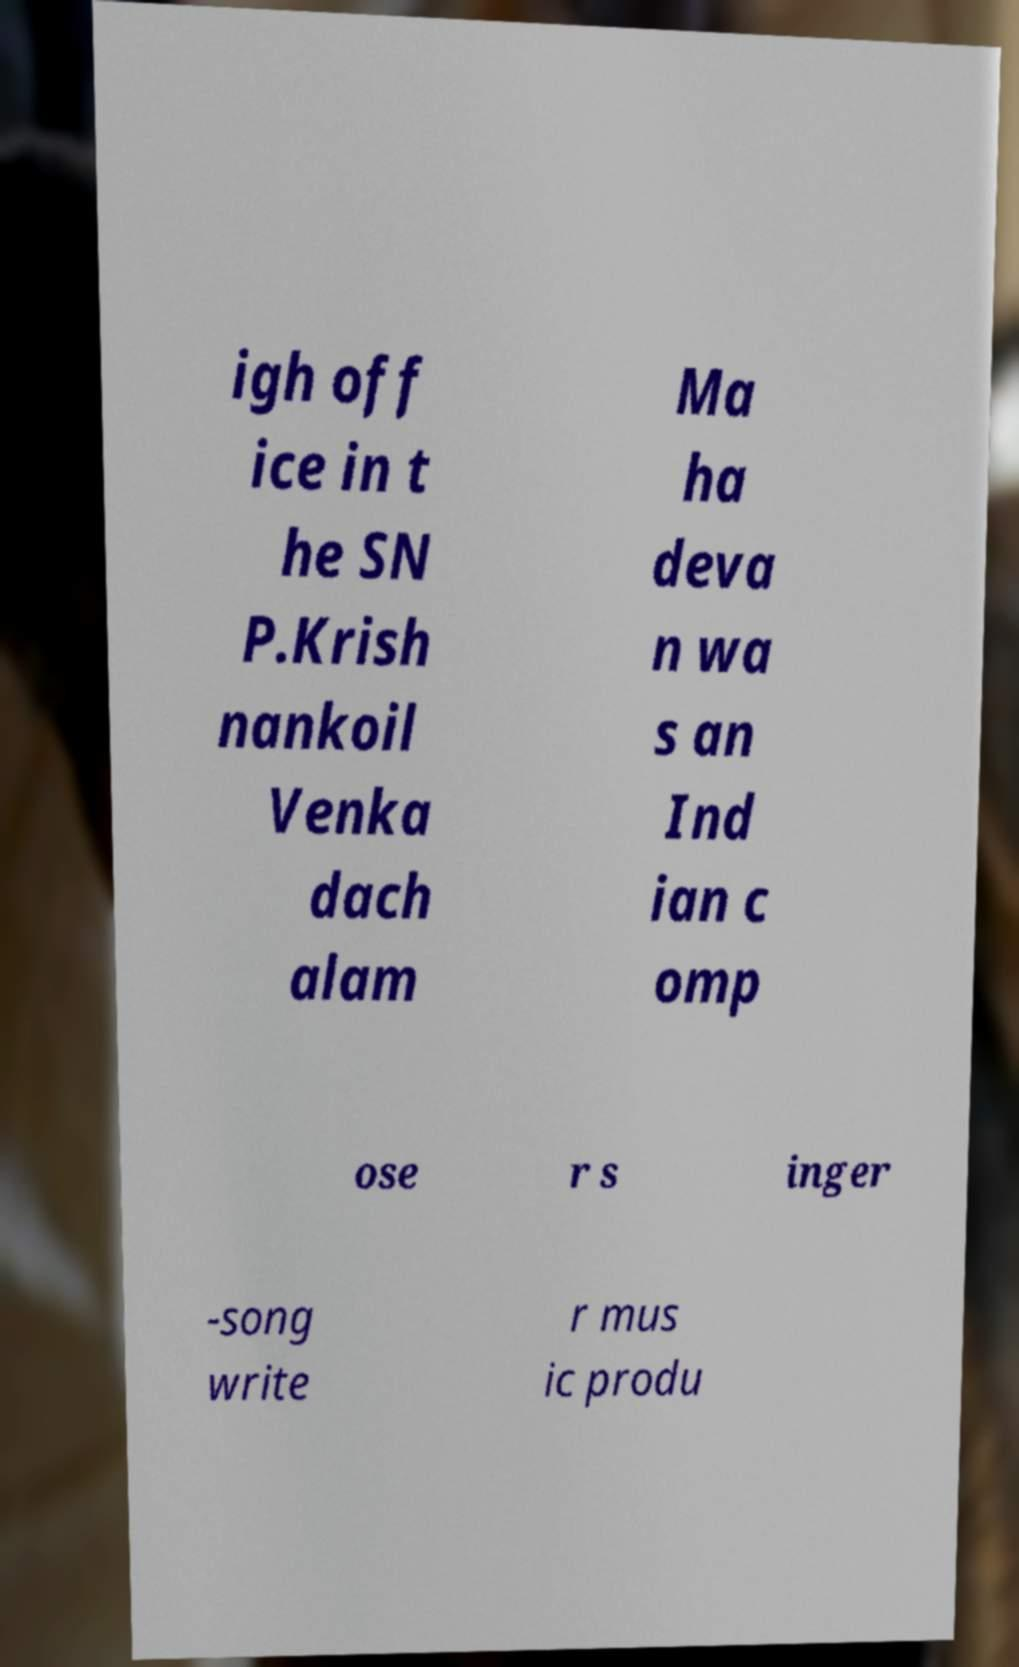Could you extract and type out the text from this image? igh off ice in t he SN P.Krish nankoil Venka dach alam Ma ha deva n wa s an Ind ian c omp ose r s inger -song write r mus ic produ 